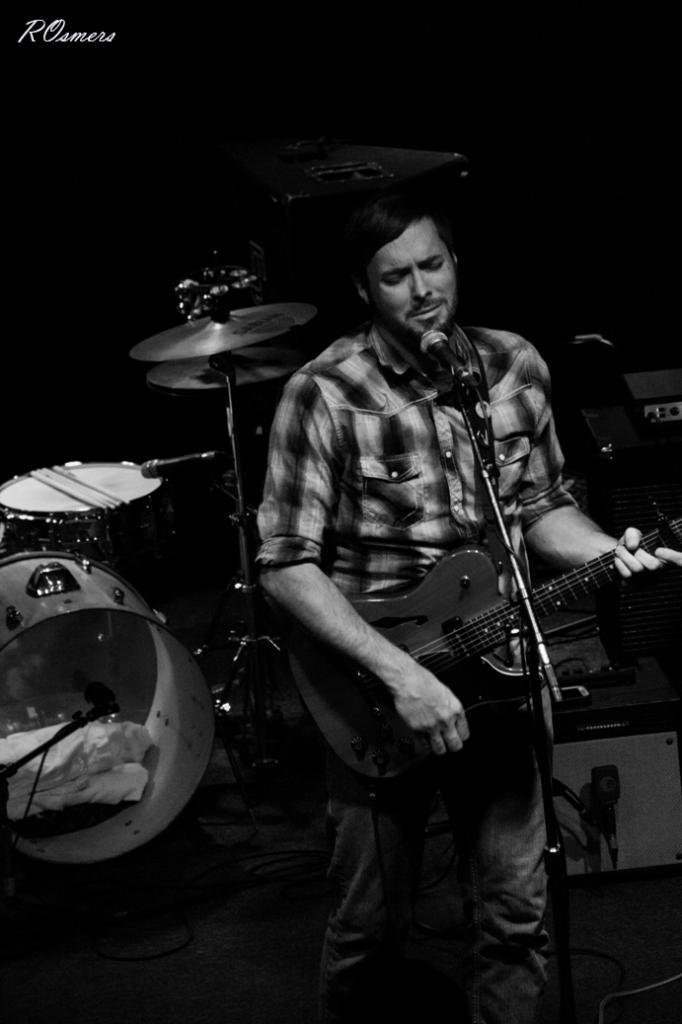Who is the main subject in the image? There is a man in the image. What is the man doing in the image? The man is standing, playing the guitar, and singing a song. What type of mice can be seen eating cabbage in the image? There are no mice or cabbage present in the image; it features a man playing the guitar and singing a song. How many mittens is the man wearing in the image? The man is not wearing any mittens in the image. 